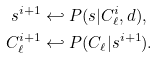Convert formula to latex. <formula><loc_0><loc_0><loc_500><loc_500>s ^ { i + 1 } & \hookleftarrow P ( s | C _ { \ell } ^ { i } , d ) , \\ C _ { \ell } ^ { i + 1 } & \hookleftarrow P ( C _ { \ell } | s ^ { i + 1 } ) .</formula> 